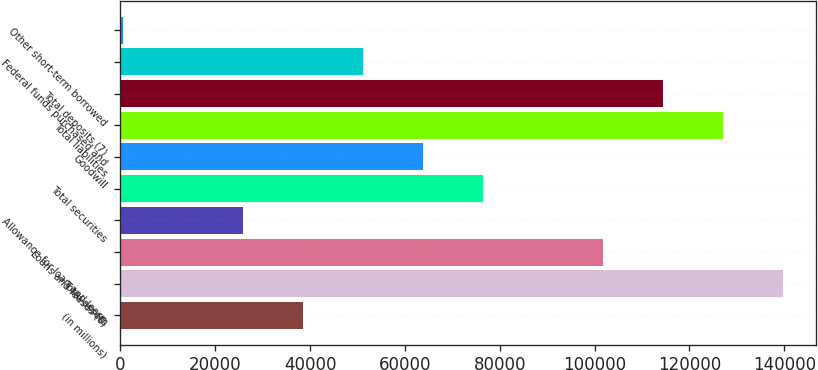Convert chart to OTSL. <chart><loc_0><loc_0><loc_500><loc_500><bar_chart><fcel>(in millions)<fcel>Total assets<fcel>Loans and leases (6)<fcel>Allowance for loan and lease<fcel>Total securities<fcel>Goodwill<fcel>Total liabilities<fcel>Total deposits (7)<fcel>Federal funds purchased and<fcel>Other short-term borrowed<nl><fcel>38466.6<fcel>139708<fcel>101743<fcel>25811.4<fcel>76432.2<fcel>63777<fcel>127053<fcel>114398<fcel>51121.8<fcel>501<nl></chart> 